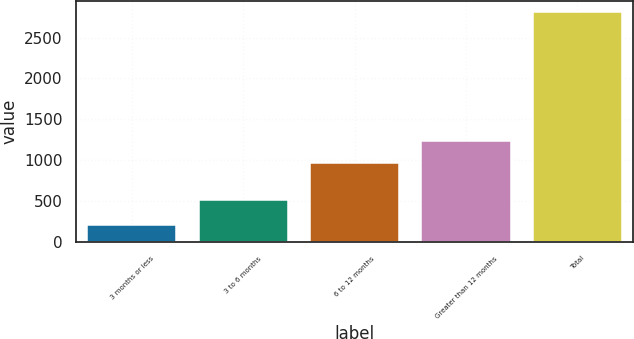<chart> <loc_0><loc_0><loc_500><loc_500><bar_chart><fcel>3 months or less<fcel>3 to 6 months<fcel>6 to 12 months<fcel>Greater than 12 months<fcel>Total<nl><fcel>212<fcel>515<fcel>971<fcel>1230.9<fcel>2811<nl></chart> 